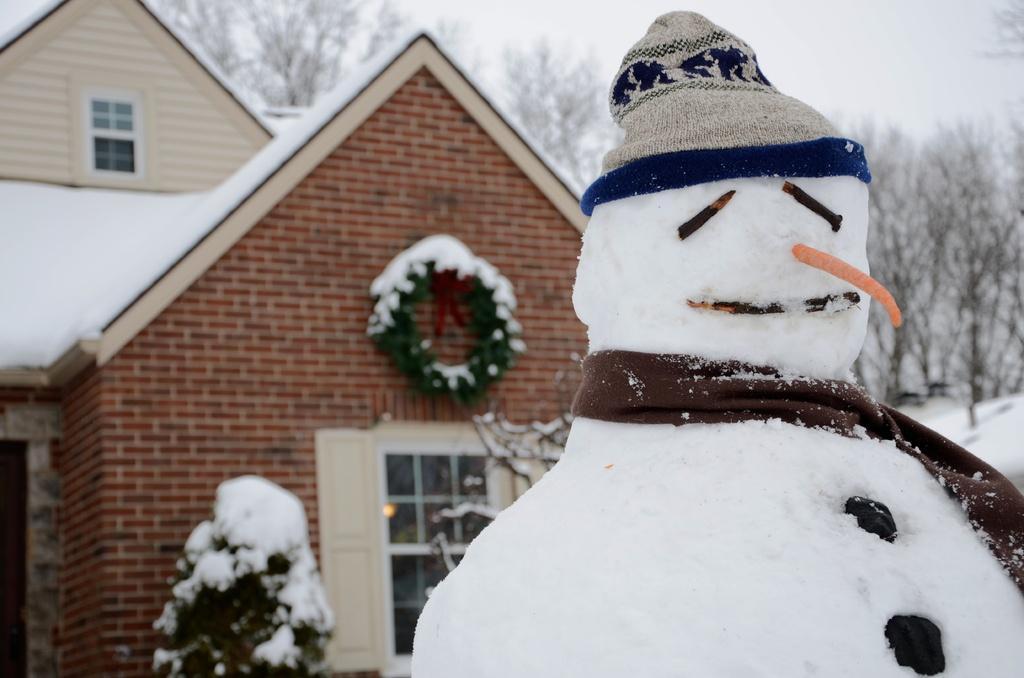Can you describe this image briefly? In this image I can see a snowman wearing brown colored scarf and a cap. In the background I can see a building which is made up of bricks, a Christmas tree, the window of the building, few trees and the snow. 